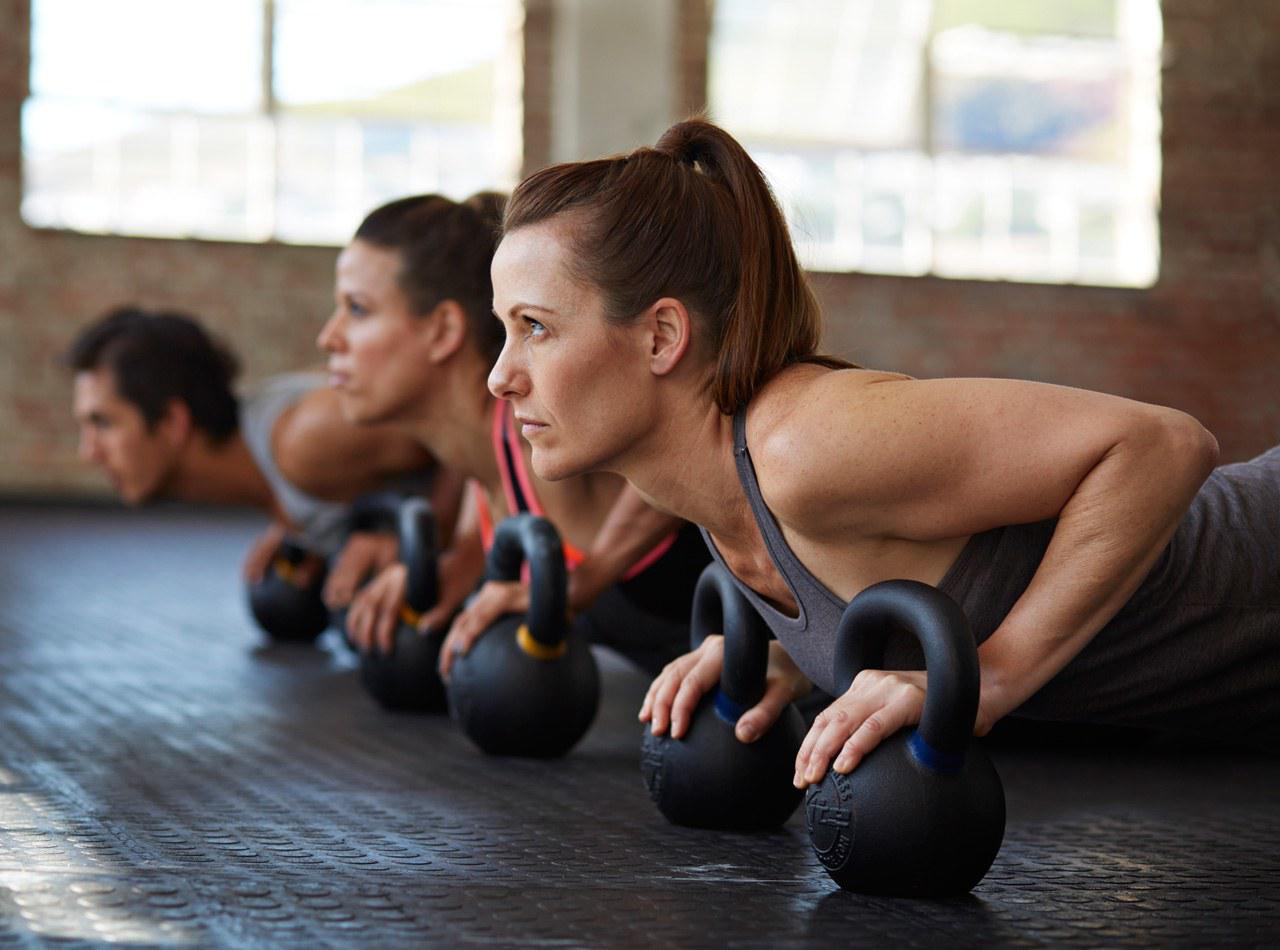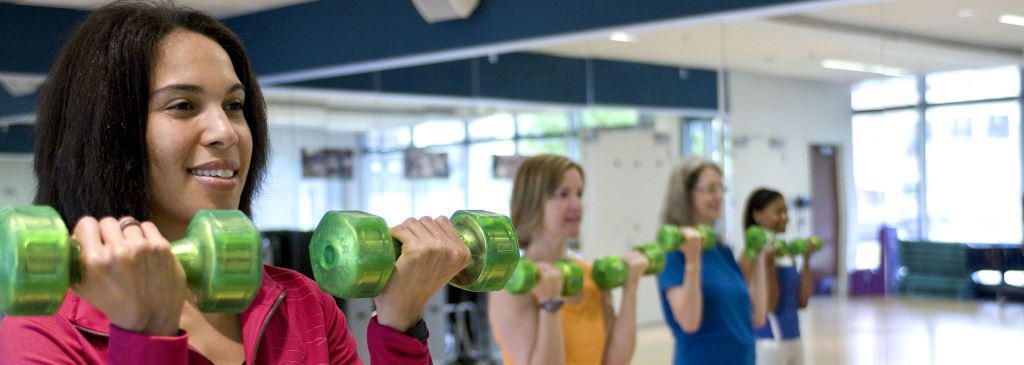The first image is the image on the left, the second image is the image on the right. Examine the images to the left and right. Is the description "In one of the images, someone is exercising, and in the other image, people are posing." accurate? Answer yes or no. No. 